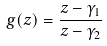<formula> <loc_0><loc_0><loc_500><loc_500>g ( z ) = { \frac { z - \gamma _ { 1 } } { z - \gamma _ { 2 } } }</formula> 